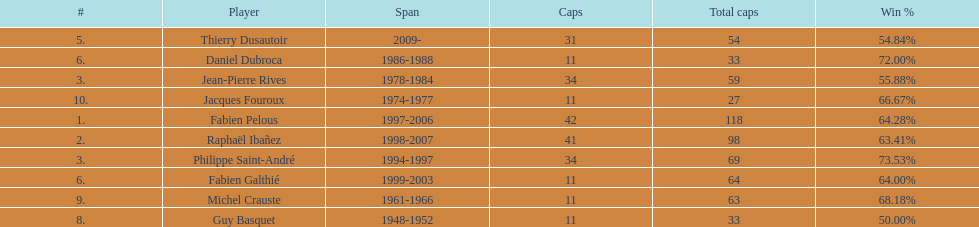Which captain served the least amount of time? Daniel Dubroca. 